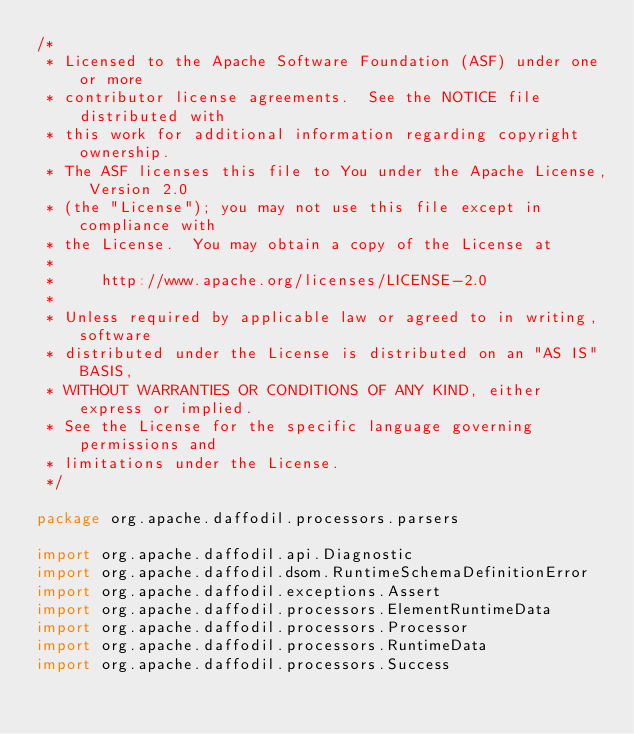<code> <loc_0><loc_0><loc_500><loc_500><_Scala_>/*
 * Licensed to the Apache Software Foundation (ASF) under one or more
 * contributor license agreements.  See the NOTICE file distributed with
 * this work for additional information regarding copyright ownership.
 * The ASF licenses this file to You under the Apache License, Version 2.0
 * (the "License"); you may not use this file except in compliance with
 * the License.  You may obtain a copy of the License at
 *
 *     http://www.apache.org/licenses/LICENSE-2.0
 *
 * Unless required by applicable law or agreed to in writing, software
 * distributed under the License is distributed on an "AS IS" BASIS,
 * WITHOUT WARRANTIES OR CONDITIONS OF ANY KIND, either express or implied.
 * See the License for the specific language governing permissions and
 * limitations under the License.
 */

package org.apache.daffodil.processors.parsers

import org.apache.daffodil.api.Diagnostic
import org.apache.daffodil.dsom.RuntimeSchemaDefinitionError
import org.apache.daffodil.exceptions.Assert
import org.apache.daffodil.processors.ElementRuntimeData
import org.apache.daffodil.processors.Processor
import org.apache.daffodil.processors.RuntimeData
import org.apache.daffodil.processors.Success</code> 